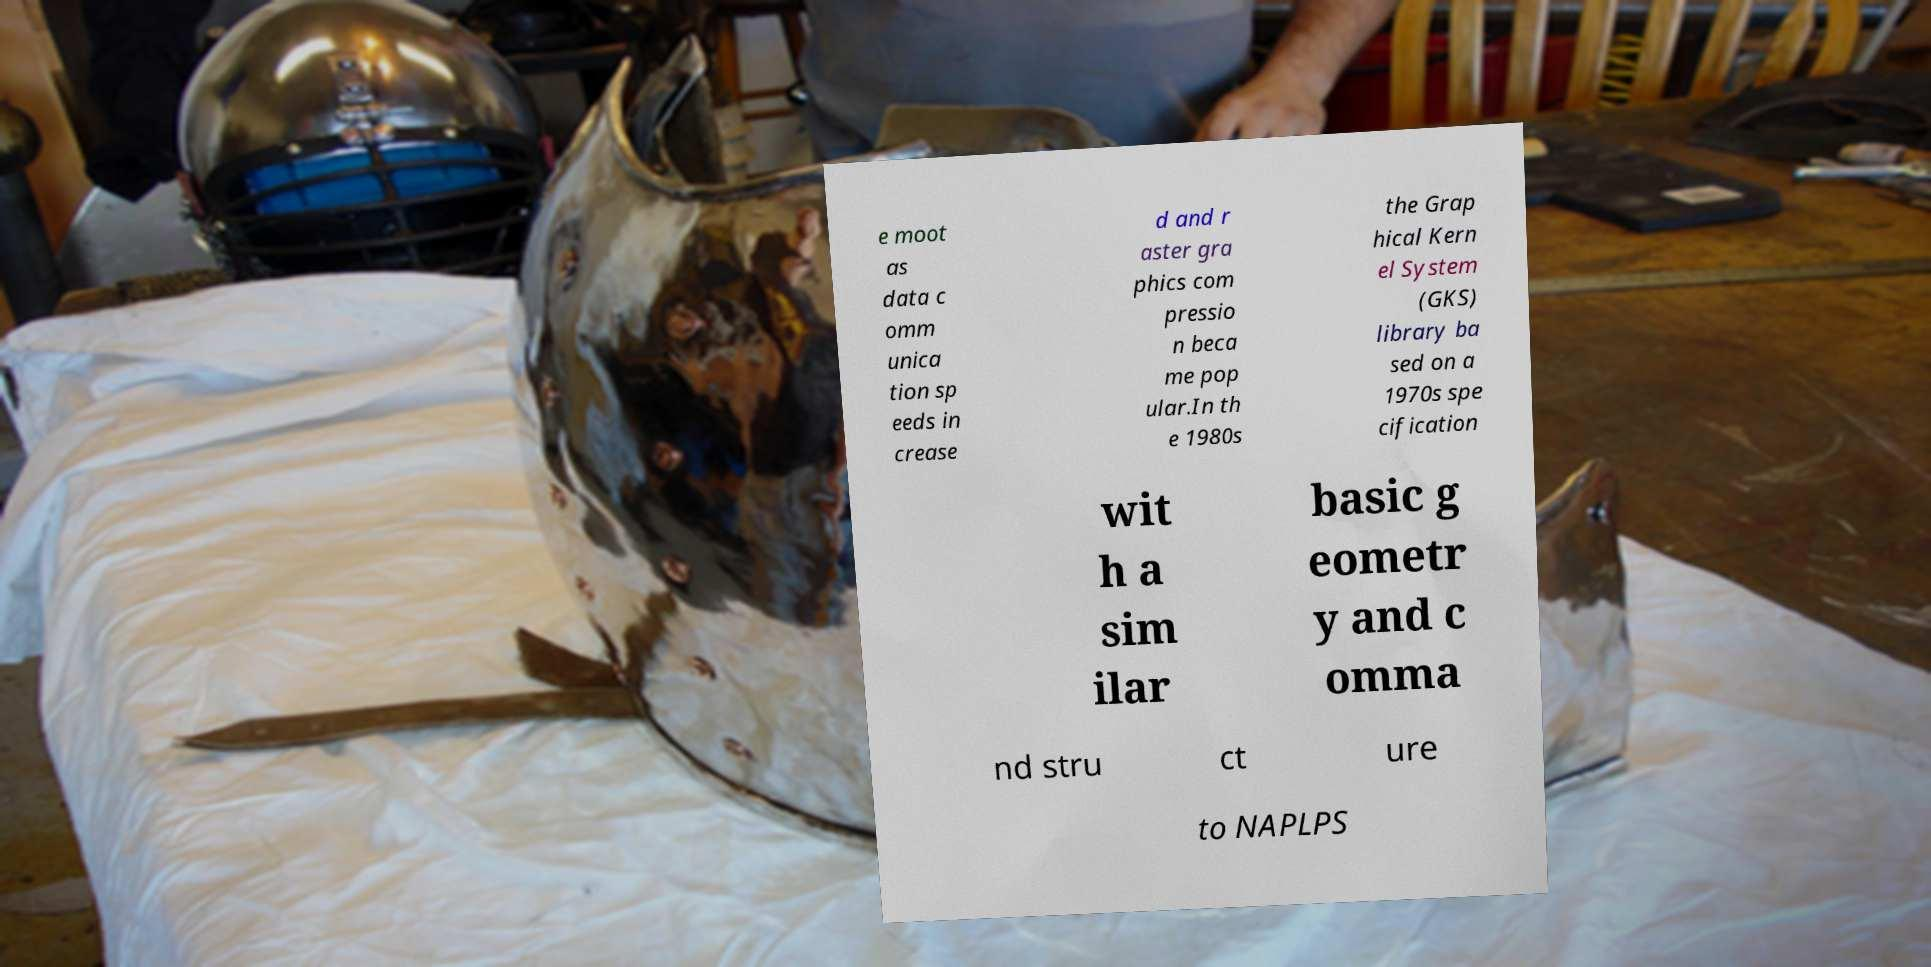Can you read and provide the text displayed in the image?This photo seems to have some interesting text. Can you extract and type it out for me? e moot as data c omm unica tion sp eeds in crease d and r aster gra phics com pressio n beca me pop ular.In th e 1980s the Grap hical Kern el System (GKS) library ba sed on a 1970s spe cification wit h a sim ilar basic g eometr y and c omma nd stru ct ure to NAPLPS 